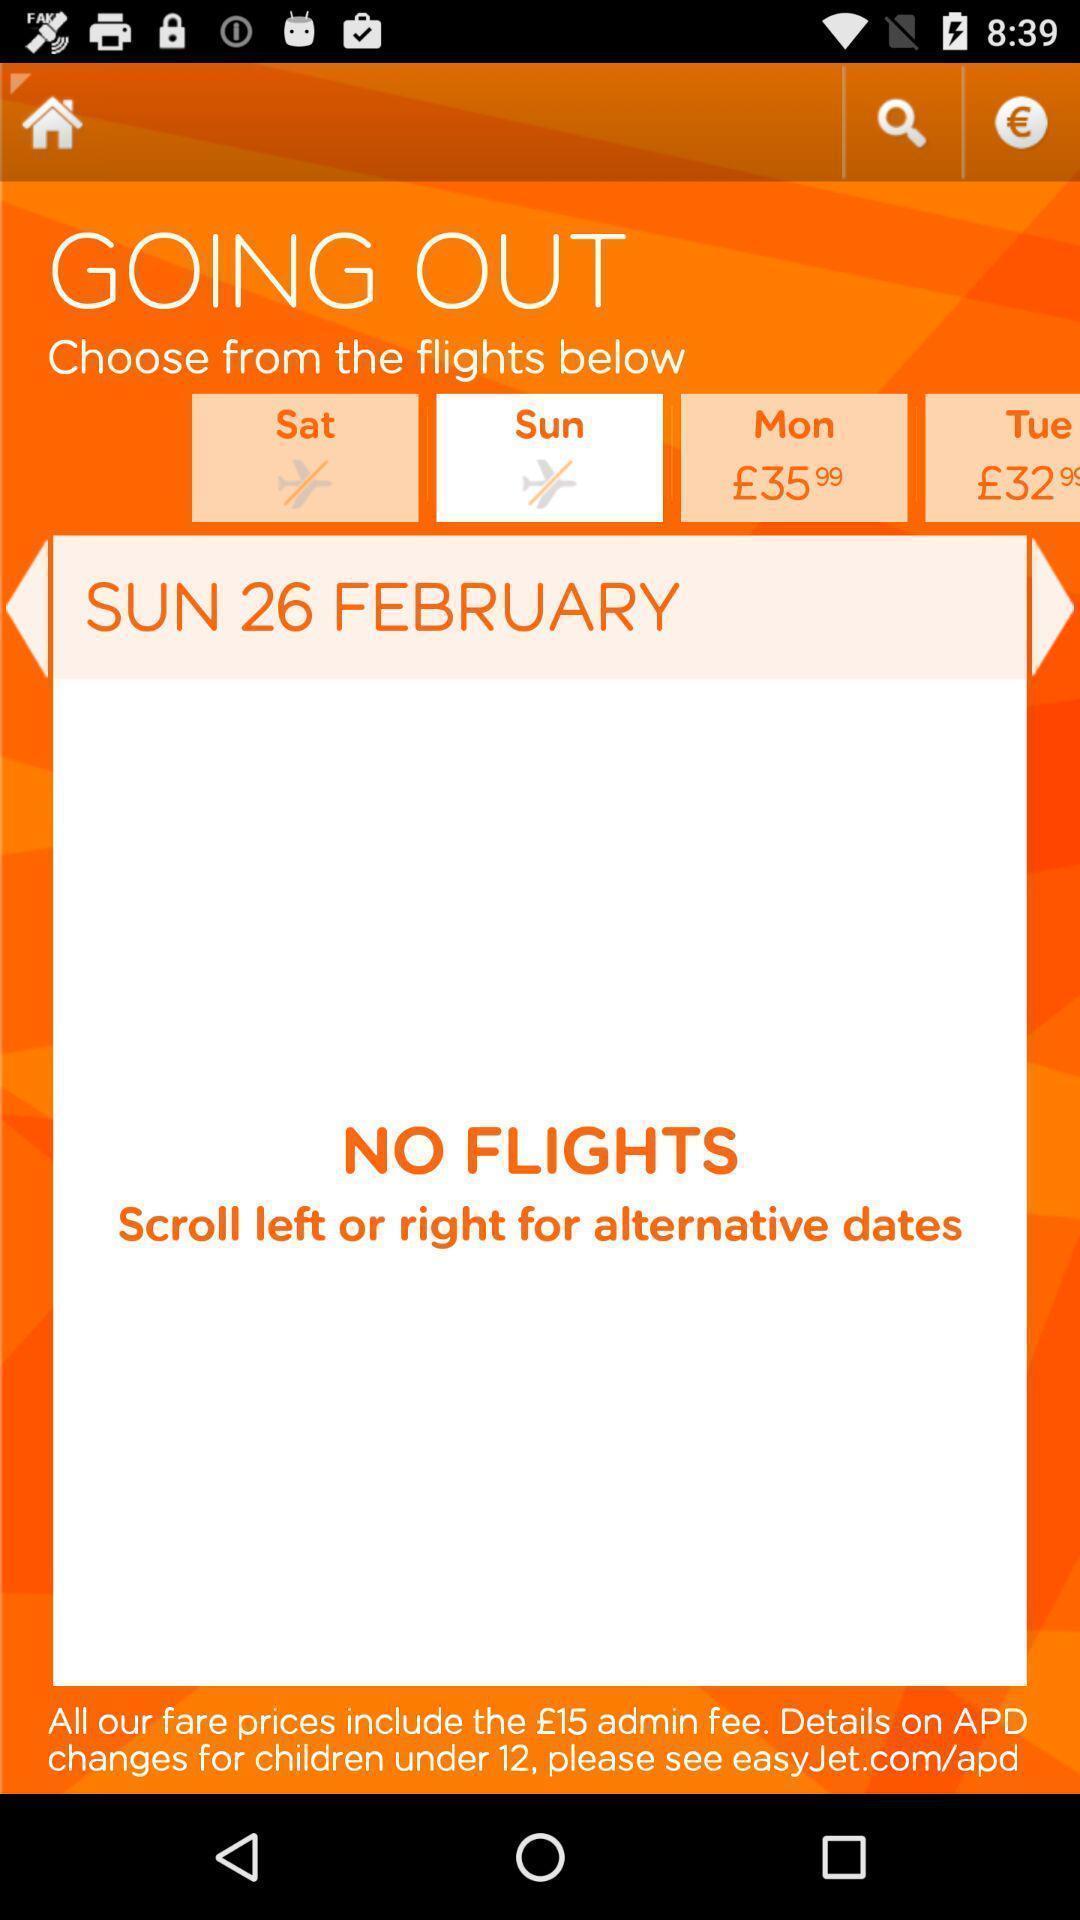What can you discern from this picture? Page showing flights details on travelling app. 